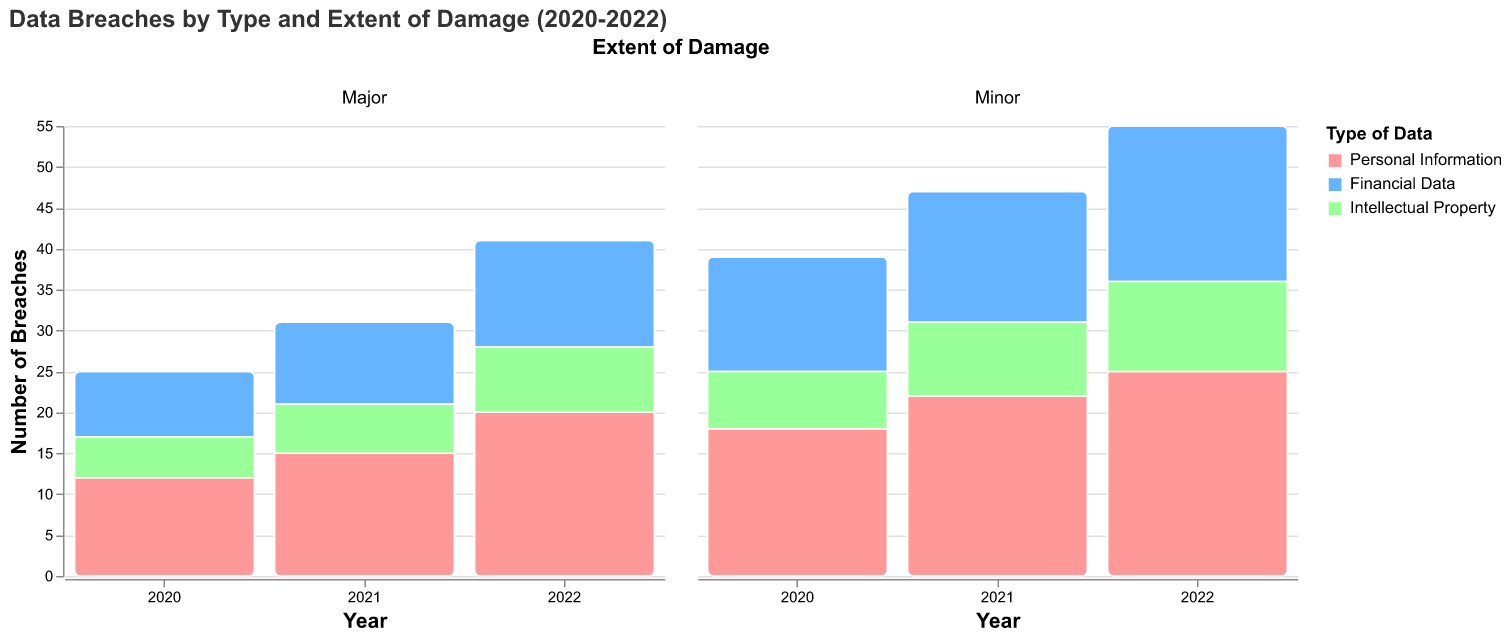How many breaches involved Personal Information in 2022 with Major extent of damage? Reference the "2022" column and "Personal Information" color in the "Major" extent section. Count is displayed directly as 20.
Answer: 20 What type of data has the highest number of breaches in 2021? Look for the highest sum in the 2021 column. Sections representing "Personal Information" are the tallest, indicating the highest number of breaches.
Answer: Personal Information Did the count of Financial Data breaches with Minor extent increase or decrease from 2020 to 2022? Compare the heights of the "Financial Data" sections under the "Minor" extent column for 2020 and 2022. The height increased from 14 to 19.
Answer: Increase Which year had the least number of Intellectual Property breaches with Major extent of damage? Compare the heights across the years for "Intellectual Property" in the "Major" extent section. 2020 is the shortest with 5 breaches.
Answer: 2020 What is the total number of breaches reported in 2021? Sum all heights in the 2021 column across all data types and extents: 15+22 (Personal Information) + 10+16 (Financial Data) + 6+9 (Intellectual Property) = 78.
Answer: 78 Compare the extent of damage for breaches involving Financial Data: is Minor or Major more frequent in 2022? In the 2022 column, compare the heights of "Financial Data" for "Minor" (19) and "Major" (13). Minor is taller.
Answer: Minor How did the breaches involving Intellectual Property with Minor extent of damage change from 2020 to 2021 and then to 2022? Track the height for "Intellectual Property" under "Minor" extent across the years (7 in 2020, 9 in 2021, 11 in 2022). It shows a trend of increase each year.
Answer: Increased each year What trend can you observe in breaches involving Personal Information from 2020 to 2022? Observe the heights for "Personal Information" across the years in both extents. Both Major (12, 15, 20) and Minor (18, 22, 25) breach counts show a consistent increase.
Answer: Consistent increase In which year did Financial Data experience the highest number of breaches with Major extent? Compare the heights of "Financial Data" under the "Major" extent section across all years. 2022 is the highest with 13 breaches.
Answer: 2022 Which data type shows relatively stable breach counts between Minor and Major extents across all years? Compare the relative height consistency for minor and major damage across all years for each data type. "Intellectual Property" shows relatively stable counts with less variation between Minor and Major extents.
Answer: Intellectual Property 